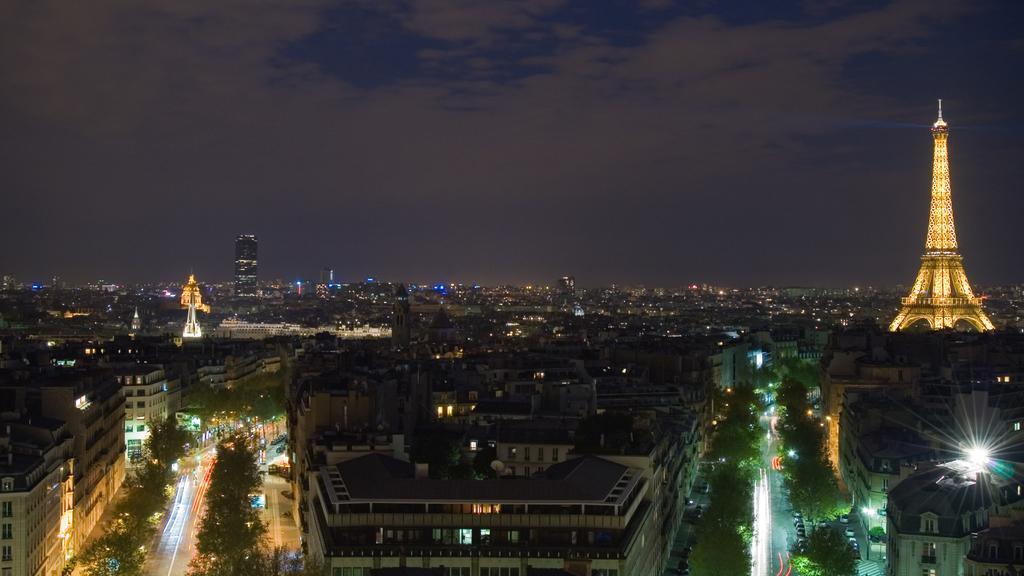Describe this image in one or two sentences. In this picture we can see an Eiffel tower, buildings, lights, trees and some objects. We can see sky in the background. 